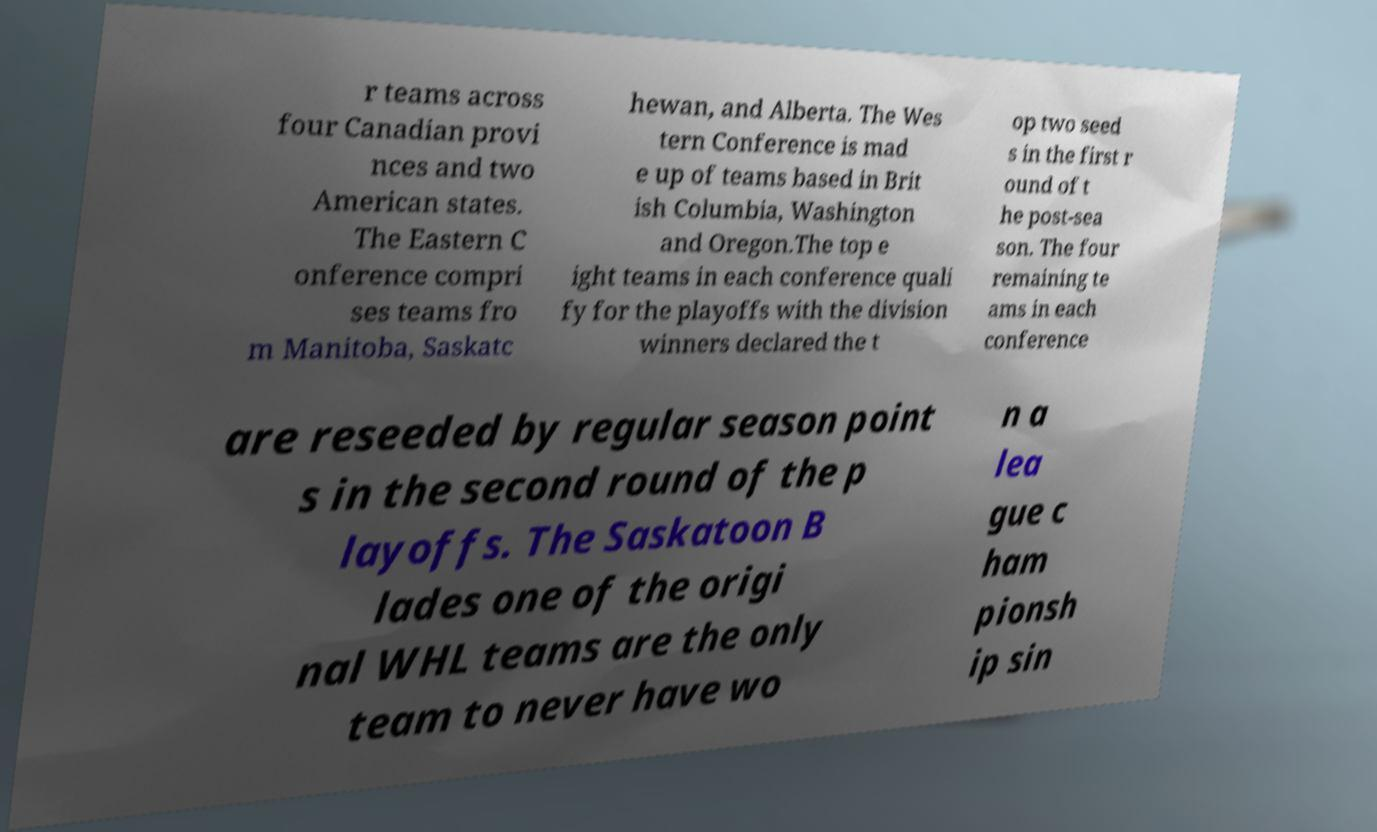For documentation purposes, I need the text within this image transcribed. Could you provide that? r teams across four Canadian provi nces and two American states. The Eastern C onference compri ses teams fro m Manitoba, Saskatc hewan, and Alberta. The Wes tern Conference is mad e up of teams based in Brit ish Columbia, Washington and Oregon.The top e ight teams in each conference quali fy for the playoffs with the division winners declared the t op two seed s in the first r ound of t he post-sea son. The four remaining te ams in each conference are reseeded by regular season point s in the second round of the p layoffs. The Saskatoon B lades one of the origi nal WHL teams are the only team to never have wo n a lea gue c ham pionsh ip sin 